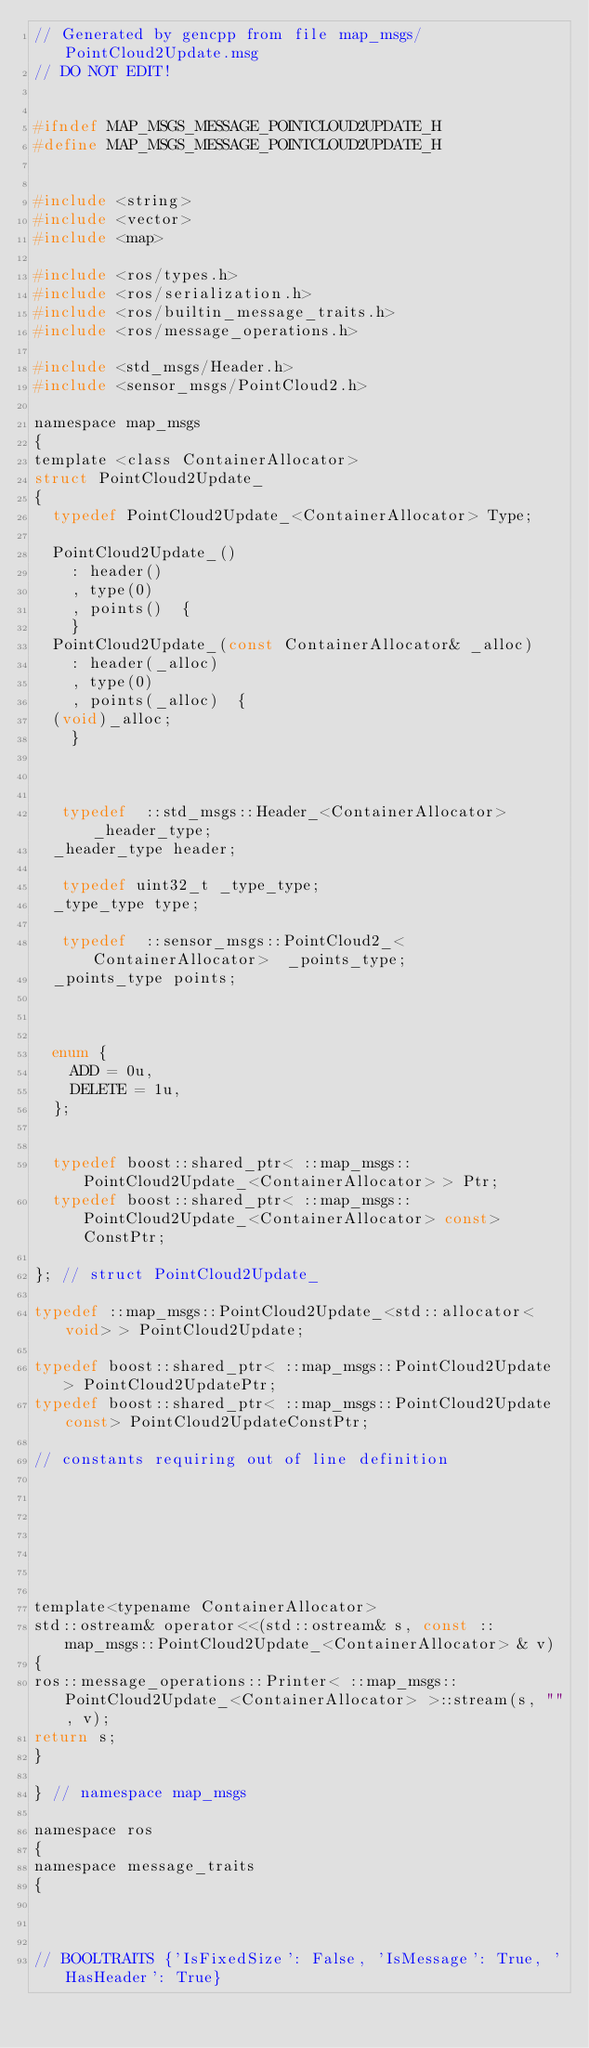Convert code to text. <code><loc_0><loc_0><loc_500><loc_500><_C_>// Generated by gencpp from file map_msgs/PointCloud2Update.msg
// DO NOT EDIT!


#ifndef MAP_MSGS_MESSAGE_POINTCLOUD2UPDATE_H
#define MAP_MSGS_MESSAGE_POINTCLOUD2UPDATE_H


#include <string>
#include <vector>
#include <map>

#include <ros/types.h>
#include <ros/serialization.h>
#include <ros/builtin_message_traits.h>
#include <ros/message_operations.h>

#include <std_msgs/Header.h>
#include <sensor_msgs/PointCloud2.h>

namespace map_msgs
{
template <class ContainerAllocator>
struct PointCloud2Update_
{
  typedef PointCloud2Update_<ContainerAllocator> Type;

  PointCloud2Update_()
    : header()
    , type(0)
    , points()  {
    }
  PointCloud2Update_(const ContainerAllocator& _alloc)
    : header(_alloc)
    , type(0)
    , points(_alloc)  {
  (void)_alloc;
    }



   typedef  ::std_msgs::Header_<ContainerAllocator>  _header_type;
  _header_type header;

   typedef uint32_t _type_type;
  _type_type type;

   typedef  ::sensor_msgs::PointCloud2_<ContainerAllocator>  _points_type;
  _points_type points;



  enum {
    ADD = 0u,
    DELETE = 1u,
  };


  typedef boost::shared_ptr< ::map_msgs::PointCloud2Update_<ContainerAllocator> > Ptr;
  typedef boost::shared_ptr< ::map_msgs::PointCloud2Update_<ContainerAllocator> const> ConstPtr;

}; // struct PointCloud2Update_

typedef ::map_msgs::PointCloud2Update_<std::allocator<void> > PointCloud2Update;

typedef boost::shared_ptr< ::map_msgs::PointCloud2Update > PointCloud2UpdatePtr;
typedef boost::shared_ptr< ::map_msgs::PointCloud2Update const> PointCloud2UpdateConstPtr;

// constants requiring out of line definition

   

   



template<typename ContainerAllocator>
std::ostream& operator<<(std::ostream& s, const ::map_msgs::PointCloud2Update_<ContainerAllocator> & v)
{
ros::message_operations::Printer< ::map_msgs::PointCloud2Update_<ContainerAllocator> >::stream(s, "", v);
return s;
}

} // namespace map_msgs

namespace ros
{
namespace message_traits
{



// BOOLTRAITS {'IsFixedSize': False, 'IsMessage': True, 'HasHeader': True}</code> 